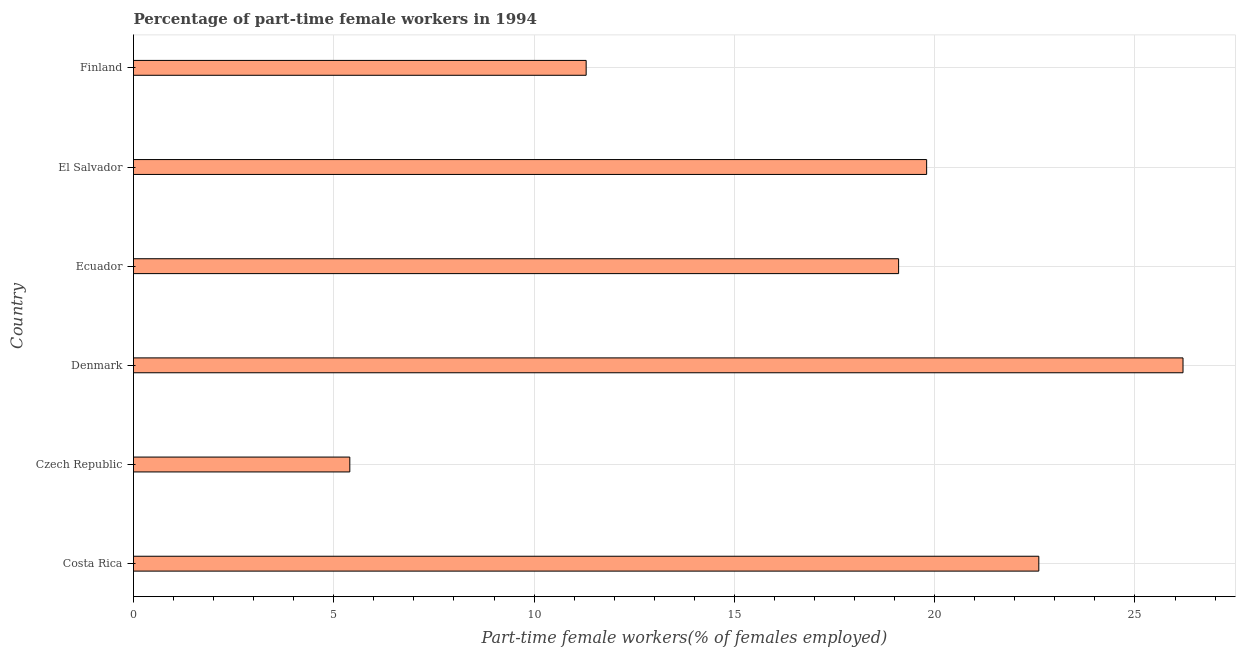Does the graph contain any zero values?
Offer a terse response. No. Does the graph contain grids?
Make the answer very short. Yes. What is the title of the graph?
Provide a short and direct response. Percentage of part-time female workers in 1994. What is the label or title of the X-axis?
Offer a very short reply. Part-time female workers(% of females employed). What is the label or title of the Y-axis?
Ensure brevity in your answer.  Country. What is the percentage of part-time female workers in Finland?
Offer a very short reply. 11.3. Across all countries, what is the maximum percentage of part-time female workers?
Keep it short and to the point. 26.2. Across all countries, what is the minimum percentage of part-time female workers?
Your answer should be compact. 5.4. In which country was the percentage of part-time female workers maximum?
Ensure brevity in your answer.  Denmark. In which country was the percentage of part-time female workers minimum?
Keep it short and to the point. Czech Republic. What is the sum of the percentage of part-time female workers?
Provide a short and direct response. 104.4. What is the difference between the percentage of part-time female workers in Czech Republic and Denmark?
Your response must be concise. -20.8. What is the average percentage of part-time female workers per country?
Give a very brief answer. 17.4. What is the median percentage of part-time female workers?
Give a very brief answer. 19.45. What is the ratio of the percentage of part-time female workers in Ecuador to that in Finland?
Ensure brevity in your answer.  1.69. Is the percentage of part-time female workers in Ecuador less than that in El Salvador?
Offer a terse response. Yes. What is the difference between the highest and the second highest percentage of part-time female workers?
Keep it short and to the point. 3.6. Is the sum of the percentage of part-time female workers in Czech Republic and Denmark greater than the maximum percentage of part-time female workers across all countries?
Provide a succinct answer. Yes. What is the difference between the highest and the lowest percentage of part-time female workers?
Provide a short and direct response. 20.8. In how many countries, is the percentage of part-time female workers greater than the average percentage of part-time female workers taken over all countries?
Your answer should be very brief. 4. How many bars are there?
Your response must be concise. 6. What is the difference between two consecutive major ticks on the X-axis?
Ensure brevity in your answer.  5. What is the Part-time female workers(% of females employed) of Costa Rica?
Your answer should be compact. 22.6. What is the Part-time female workers(% of females employed) in Czech Republic?
Your answer should be compact. 5.4. What is the Part-time female workers(% of females employed) in Denmark?
Keep it short and to the point. 26.2. What is the Part-time female workers(% of females employed) of Ecuador?
Make the answer very short. 19.1. What is the Part-time female workers(% of females employed) in El Salvador?
Offer a terse response. 19.8. What is the Part-time female workers(% of females employed) of Finland?
Your response must be concise. 11.3. What is the difference between the Part-time female workers(% of females employed) in Costa Rica and Czech Republic?
Give a very brief answer. 17.2. What is the difference between the Part-time female workers(% of females employed) in Costa Rica and Ecuador?
Your answer should be compact. 3.5. What is the difference between the Part-time female workers(% of females employed) in Costa Rica and Finland?
Keep it short and to the point. 11.3. What is the difference between the Part-time female workers(% of females employed) in Czech Republic and Denmark?
Your response must be concise. -20.8. What is the difference between the Part-time female workers(% of females employed) in Czech Republic and Ecuador?
Your response must be concise. -13.7. What is the difference between the Part-time female workers(% of females employed) in Czech Republic and El Salvador?
Offer a terse response. -14.4. What is the difference between the Part-time female workers(% of females employed) in Denmark and El Salvador?
Provide a short and direct response. 6.4. What is the difference between the Part-time female workers(% of females employed) in Ecuador and El Salvador?
Give a very brief answer. -0.7. What is the difference between the Part-time female workers(% of females employed) in Ecuador and Finland?
Your answer should be compact. 7.8. What is the difference between the Part-time female workers(% of females employed) in El Salvador and Finland?
Your answer should be very brief. 8.5. What is the ratio of the Part-time female workers(% of females employed) in Costa Rica to that in Czech Republic?
Your response must be concise. 4.18. What is the ratio of the Part-time female workers(% of females employed) in Costa Rica to that in Denmark?
Provide a succinct answer. 0.86. What is the ratio of the Part-time female workers(% of females employed) in Costa Rica to that in Ecuador?
Give a very brief answer. 1.18. What is the ratio of the Part-time female workers(% of females employed) in Costa Rica to that in El Salvador?
Give a very brief answer. 1.14. What is the ratio of the Part-time female workers(% of females employed) in Costa Rica to that in Finland?
Offer a terse response. 2. What is the ratio of the Part-time female workers(% of females employed) in Czech Republic to that in Denmark?
Ensure brevity in your answer.  0.21. What is the ratio of the Part-time female workers(% of females employed) in Czech Republic to that in Ecuador?
Provide a succinct answer. 0.28. What is the ratio of the Part-time female workers(% of females employed) in Czech Republic to that in El Salvador?
Provide a succinct answer. 0.27. What is the ratio of the Part-time female workers(% of females employed) in Czech Republic to that in Finland?
Provide a succinct answer. 0.48. What is the ratio of the Part-time female workers(% of females employed) in Denmark to that in Ecuador?
Ensure brevity in your answer.  1.37. What is the ratio of the Part-time female workers(% of females employed) in Denmark to that in El Salvador?
Make the answer very short. 1.32. What is the ratio of the Part-time female workers(% of females employed) in Denmark to that in Finland?
Provide a succinct answer. 2.32. What is the ratio of the Part-time female workers(% of females employed) in Ecuador to that in El Salvador?
Your answer should be very brief. 0.96. What is the ratio of the Part-time female workers(% of females employed) in Ecuador to that in Finland?
Your answer should be very brief. 1.69. What is the ratio of the Part-time female workers(% of females employed) in El Salvador to that in Finland?
Provide a succinct answer. 1.75. 